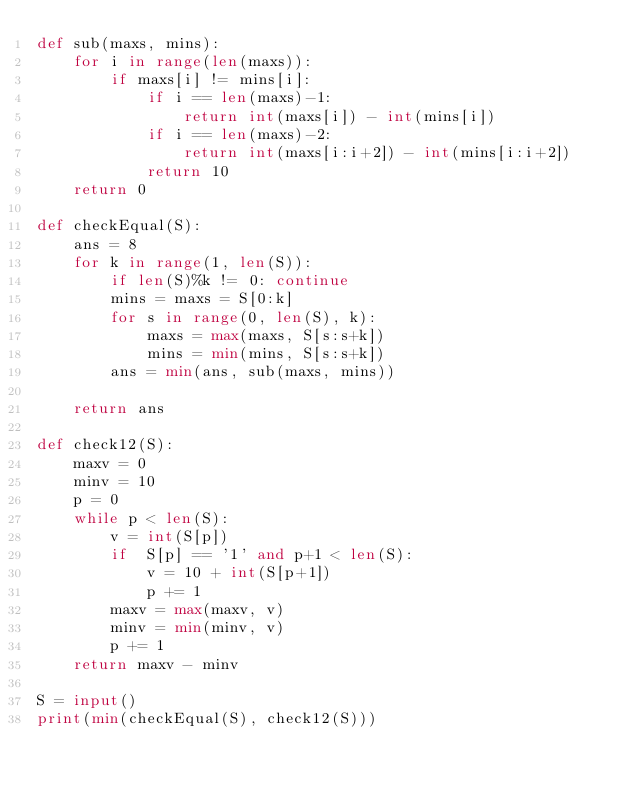Convert code to text. <code><loc_0><loc_0><loc_500><loc_500><_Python_>def sub(maxs, mins):
    for i in range(len(maxs)):
        if maxs[i] != mins[i]:
            if i == len(maxs)-1:
                return int(maxs[i]) - int(mins[i])
            if i == len(maxs)-2:
                return int(maxs[i:i+2]) - int(mins[i:i+2])
            return 10
    return 0

def checkEqual(S):
    ans = 8
    for k in range(1, len(S)):
        if len(S)%k != 0: continue
        mins = maxs = S[0:k]
        for s in range(0, len(S), k):
            maxs = max(maxs, S[s:s+k])
            mins = min(mins, S[s:s+k])
        ans = min(ans, sub(maxs, mins))

    return ans

def check12(S):
    maxv = 0
    minv = 10
    p = 0
    while p < len(S):
        v = int(S[p])
        if  S[p] == '1' and p+1 < len(S):
            v = 10 + int(S[p+1])
            p += 1
        maxv = max(maxv, v)
        minv = min(minv, v)
        p += 1
    return maxv - minv

S = input()
print(min(checkEqual(S), check12(S)))
                                                                                                                        
</code> 